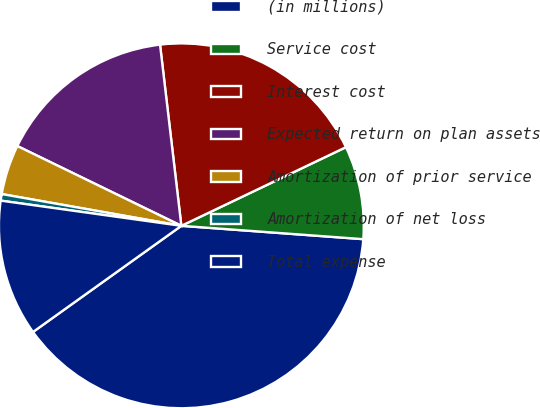Convert chart. <chart><loc_0><loc_0><loc_500><loc_500><pie_chart><fcel>(in millions)<fcel>Service cost<fcel>Interest cost<fcel>Expected return on plan assets<fcel>Amortization of prior service<fcel>Amortization of net loss<fcel>Total expense<nl><fcel>38.95%<fcel>8.26%<fcel>19.77%<fcel>15.93%<fcel>4.42%<fcel>0.58%<fcel>12.09%<nl></chart> 